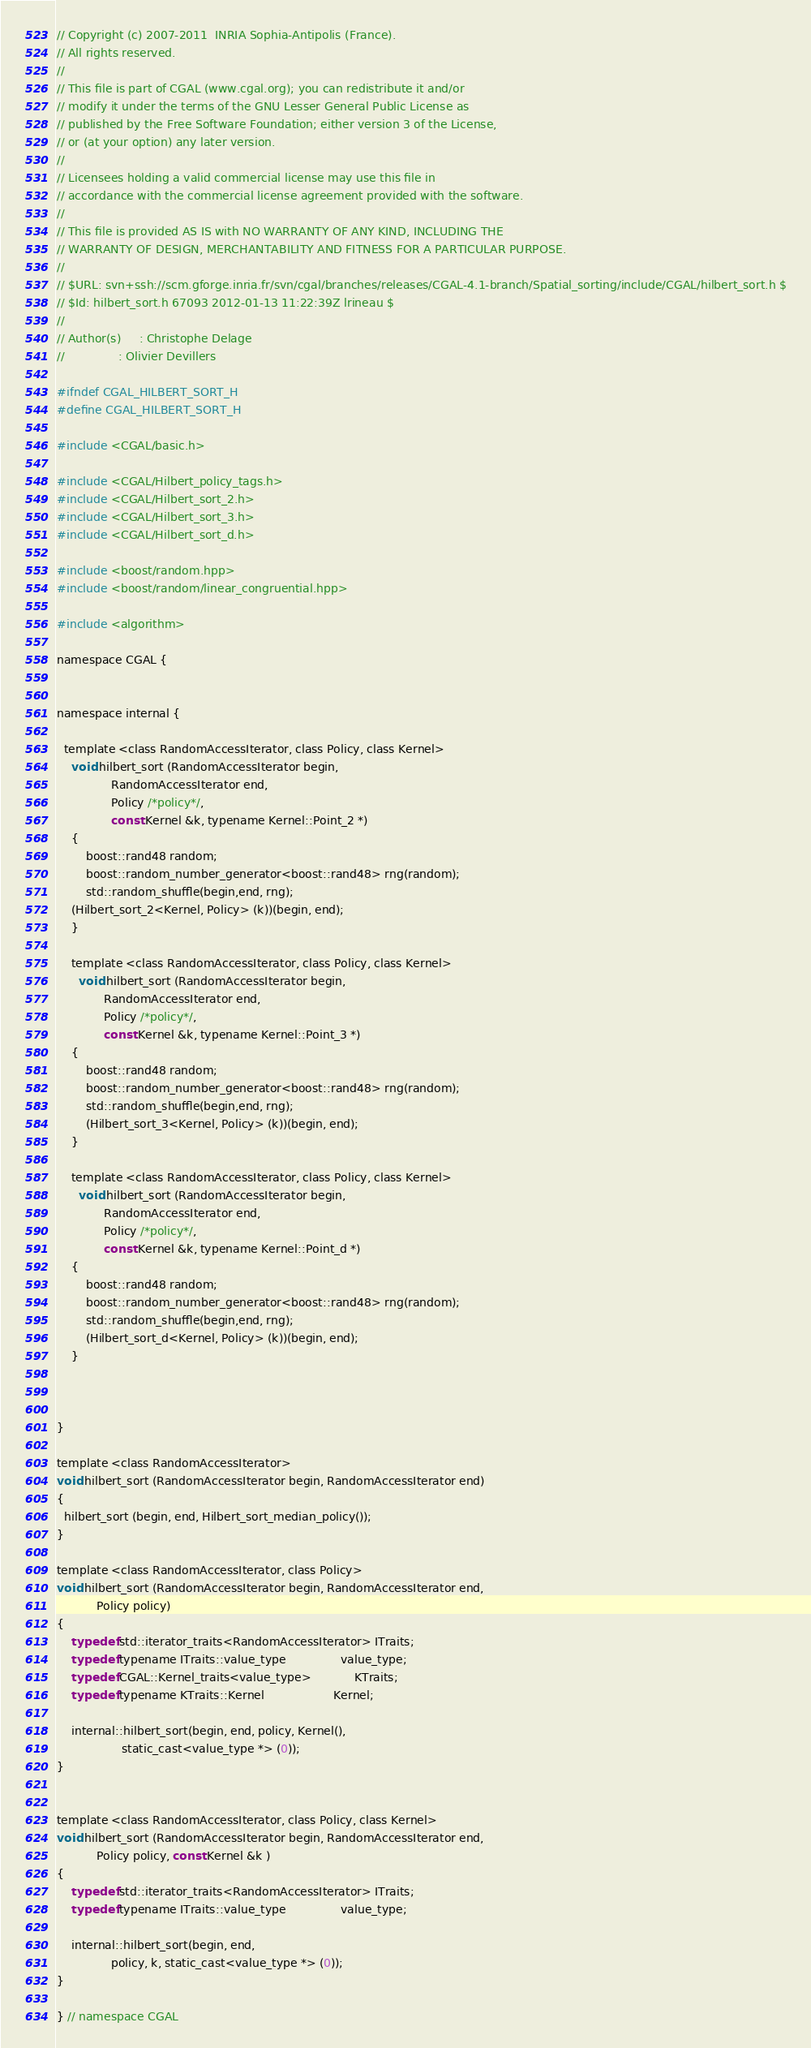<code> <loc_0><loc_0><loc_500><loc_500><_C_>// Copyright (c) 2007-2011  INRIA Sophia-Antipolis (France).
// All rights reserved.
//
// This file is part of CGAL (www.cgal.org); you can redistribute it and/or
// modify it under the terms of the GNU Lesser General Public License as
// published by the Free Software Foundation; either version 3 of the License,
// or (at your option) any later version.
//
// Licensees holding a valid commercial license may use this file in
// accordance with the commercial license agreement provided with the software.
//
// This file is provided AS IS with NO WARRANTY OF ANY KIND, INCLUDING THE
// WARRANTY OF DESIGN, MERCHANTABILITY AND FITNESS FOR A PARTICULAR PURPOSE.
//
// $URL: svn+ssh://scm.gforge.inria.fr/svn/cgal/branches/releases/CGAL-4.1-branch/Spatial_sorting/include/CGAL/hilbert_sort.h $
// $Id: hilbert_sort.h 67093 2012-01-13 11:22:39Z lrineau $
//
// Author(s)     : Christophe Delage
//               : Olivier Devillers

#ifndef CGAL_HILBERT_SORT_H
#define CGAL_HILBERT_SORT_H

#include <CGAL/basic.h>

#include <CGAL/Hilbert_policy_tags.h>
#include <CGAL/Hilbert_sort_2.h>
#include <CGAL/Hilbert_sort_3.h>
#include <CGAL/Hilbert_sort_d.h>

#include <boost/random.hpp>
#include <boost/random/linear_congruential.hpp>

#include <algorithm>

namespace CGAL {


namespace internal {

  template <class RandomAccessIterator, class Policy, class Kernel>
    void hilbert_sort (RandomAccessIterator begin, 
		       RandomAccessIterator end,
		       Policy /*policy*/,
		       const Kernel &k, typename Kernel::Point_2 *)
    {
        boost::rand48 random;
        boost::random_number_generator<boost::rand48> rng(random);
        std::random_shuffle(begin,end, rng);
	(Hilbert_sort_2<Kernel, Policy> (k))(begin, end);
    }
    
    template <class RandomAccessIterator, class Policy, class Kernel>
      void hilbert_sort (RandomAccessIterator begin, 
			 RandomAccessIterator end,
			 Policy /*policy*/,
			 const Kernel &k, typename Kernel::Point_3 *)
    {
        boost::rand48 random;
        boost::random_number_generator<boost::rand48> rng(random);
        std::random_shuffle(begin,end, rng);
        (Hilbert_sort_3<Kernel, Policy> (k))(begin, end);
    }

    template <class RandomAccessIterator, class Policy, class Kernel>
      void hilbert_sort (RandomAccessIterator begin,
			 RandomAccessIterator end,
			 Policy /*policy*/,
			 const Kernel &k, typename Kernel::Point_d *)
    {
        boost::rand48 random;
        boost::random_number_generator<boost::rand48> rng(random);
        std::random_shuffle(begin,end, rng);
        (Hilbert_sort_d<Kernel, Policy> (k))(begin, end);
    }
    


}

template <class RandomAccessIterator>
void hilbert_sort (RandomAccessIterator begin, RandomAccessIterator end)
{
  hilbert_sort (begin, end, Hilbert_sort_median_policy());
}

template <class RandomAccessIterator, class Policy>
void hilbert_sort (RandomAccessIterator begin, RandomAccessIterator end,
		   Policy policy)
{
    typedef std::iterator_traits<RandomAccessIterator> ITraits;
    typedef typename ITraits::value_type               value_type;
    typedef CGAL::Kernel_traits<value_type>            KTraits;
    typedef typename KTraits::Kernel                   Kernel;

    internal::hilbert_sort(begin, end, policy, Kernel(), 
				  static_cast<value_type *> (0));
}


template <class RandomAccessIterator, class Policy, class Kernel>
void hilbert_sort (RandomAccessIterator begin, RandomAccessIterator end,
		   Policy policy, const Kernel &k )
{
    typedef std::iterator_traits<RandomAccessIterator> ITraits;
    typedef typename ITraits::value_type               value_type;

    internal::hilbert_sort(begin, end, 
			   policy, k, static_cast<value_type *> (0));
}

} // namespace CGAL
</code> 